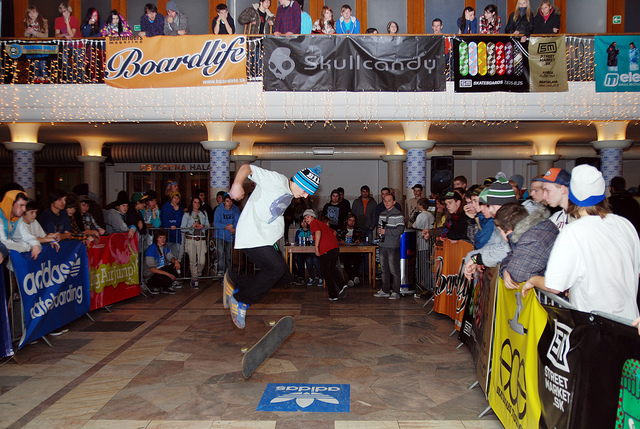Please extract the text content from this image. Boardlife Skullcandy addas SM ele Boardlife SK HEET STREET ece adidas Airpump HALF 